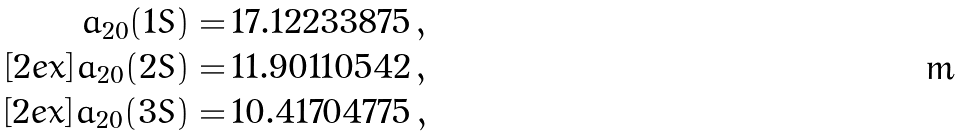Convert formula to latex. <formula><loc_0><loc_0><loc_500><loc_500>a _ { 2 0 } ( 1 S ) = & \, 1 7 . 1 2 2 3 3 8 7 5 \, , \\ [ 2 e x ] a _ { 2 0 } ( 2 S ) = & \, 1 1 . 9 0 1 1 0 5 4 2 \, , \\ [ 2 e x ] a _ { 2 0 } ( 3 S ) = & \, 1 0 . 4 1 7 0 4 7 7 5 \, ,</formula> 